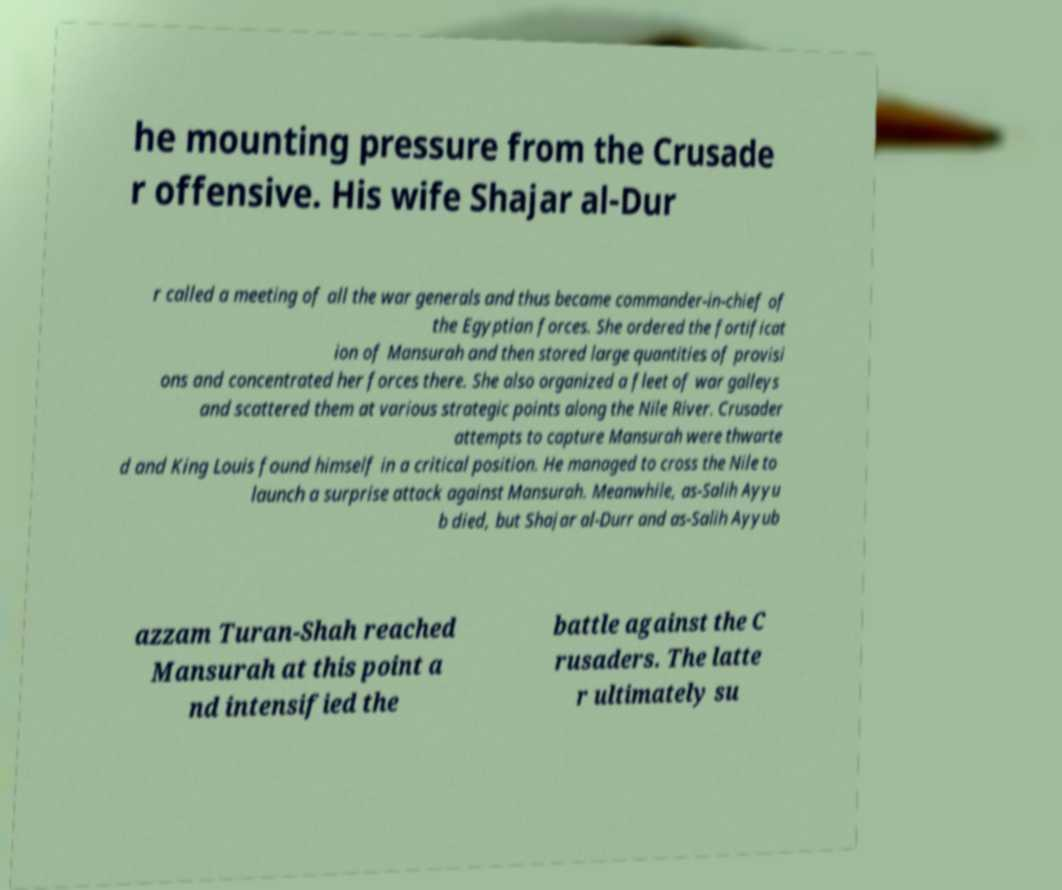There's text embedded in this image that I need extracted. Can you transcribe it verbatim? he mounting pressure from the Crusade r offensive. His wife Shajar al-Dur r called a meeting of all the war generals and thus became commander-in-chief of the Egyptian forces. She ordered the fortificat ion of Mansurah and then stored large quantities of provisi ons and concentrated her forces there. She also organized a fleet of war galleys and scattered them at various strategic points along the Nile River. Crusader attempts to capture Mansurah were thwarte d and King Louis found himself in a critical position. He managed to cross the Nile to launch a surprise attack against Mansurah. Meanwhile, as-Salih Ayyu b died, but Shajar al-Durr and as-Salih Ayyub azzam Turan-Shah reached Mansurah at this point a nd intensified the battle against the C rusaders. The latte r ultimately su 